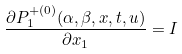<formula> <loc_0><loc_0><loc_500><loc_500>\frac { \partial P ^ { + ( 0 ) } _ { 1 } ( \alpha , \beta , x , t , u ) } { \partial x _ { 1 } } = I</formula> 